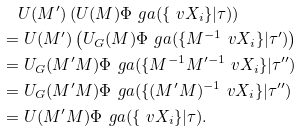<formula> <loc_0><loc_0><loc_500><loc_500>& \quad U ( M ^ { \prime } ) \left ( U ( M ) \Phi _ { \ } g a ( \{ \ v X _ { i } \} | \tau ) \right ) \\ & = U ( M ^ { \prime } ) \left ( U _ { G } ( M ) \Phi _ { \ } g a ( \{ M ^ { - 1 } \ v X _ { i } \} | \tau ^ { \prime } ) \right ) \\ & = U _ { G } ( M ^ { \prime } M ) \Phi _ { \ } g a ( \{ M ^ { - 1 } M ^ { \prime - 1 } \ v X _ { i } \} | \tau ^ { \prime \prime } ) \\ & = U _ { G } ( M ^ { \prime } M ) \Phi _ { \ } g a ( \{ ( M ^ { \prime } M ) ^ { - 1 } \ v X _ { i } \} | \tau ^ { \prime \prime } ) \\ & = U ( M ^ { \prime } M ) \Phi _ { \ } g a ( \{ \ v X _ { i } \} | \tau ) .</formula> 